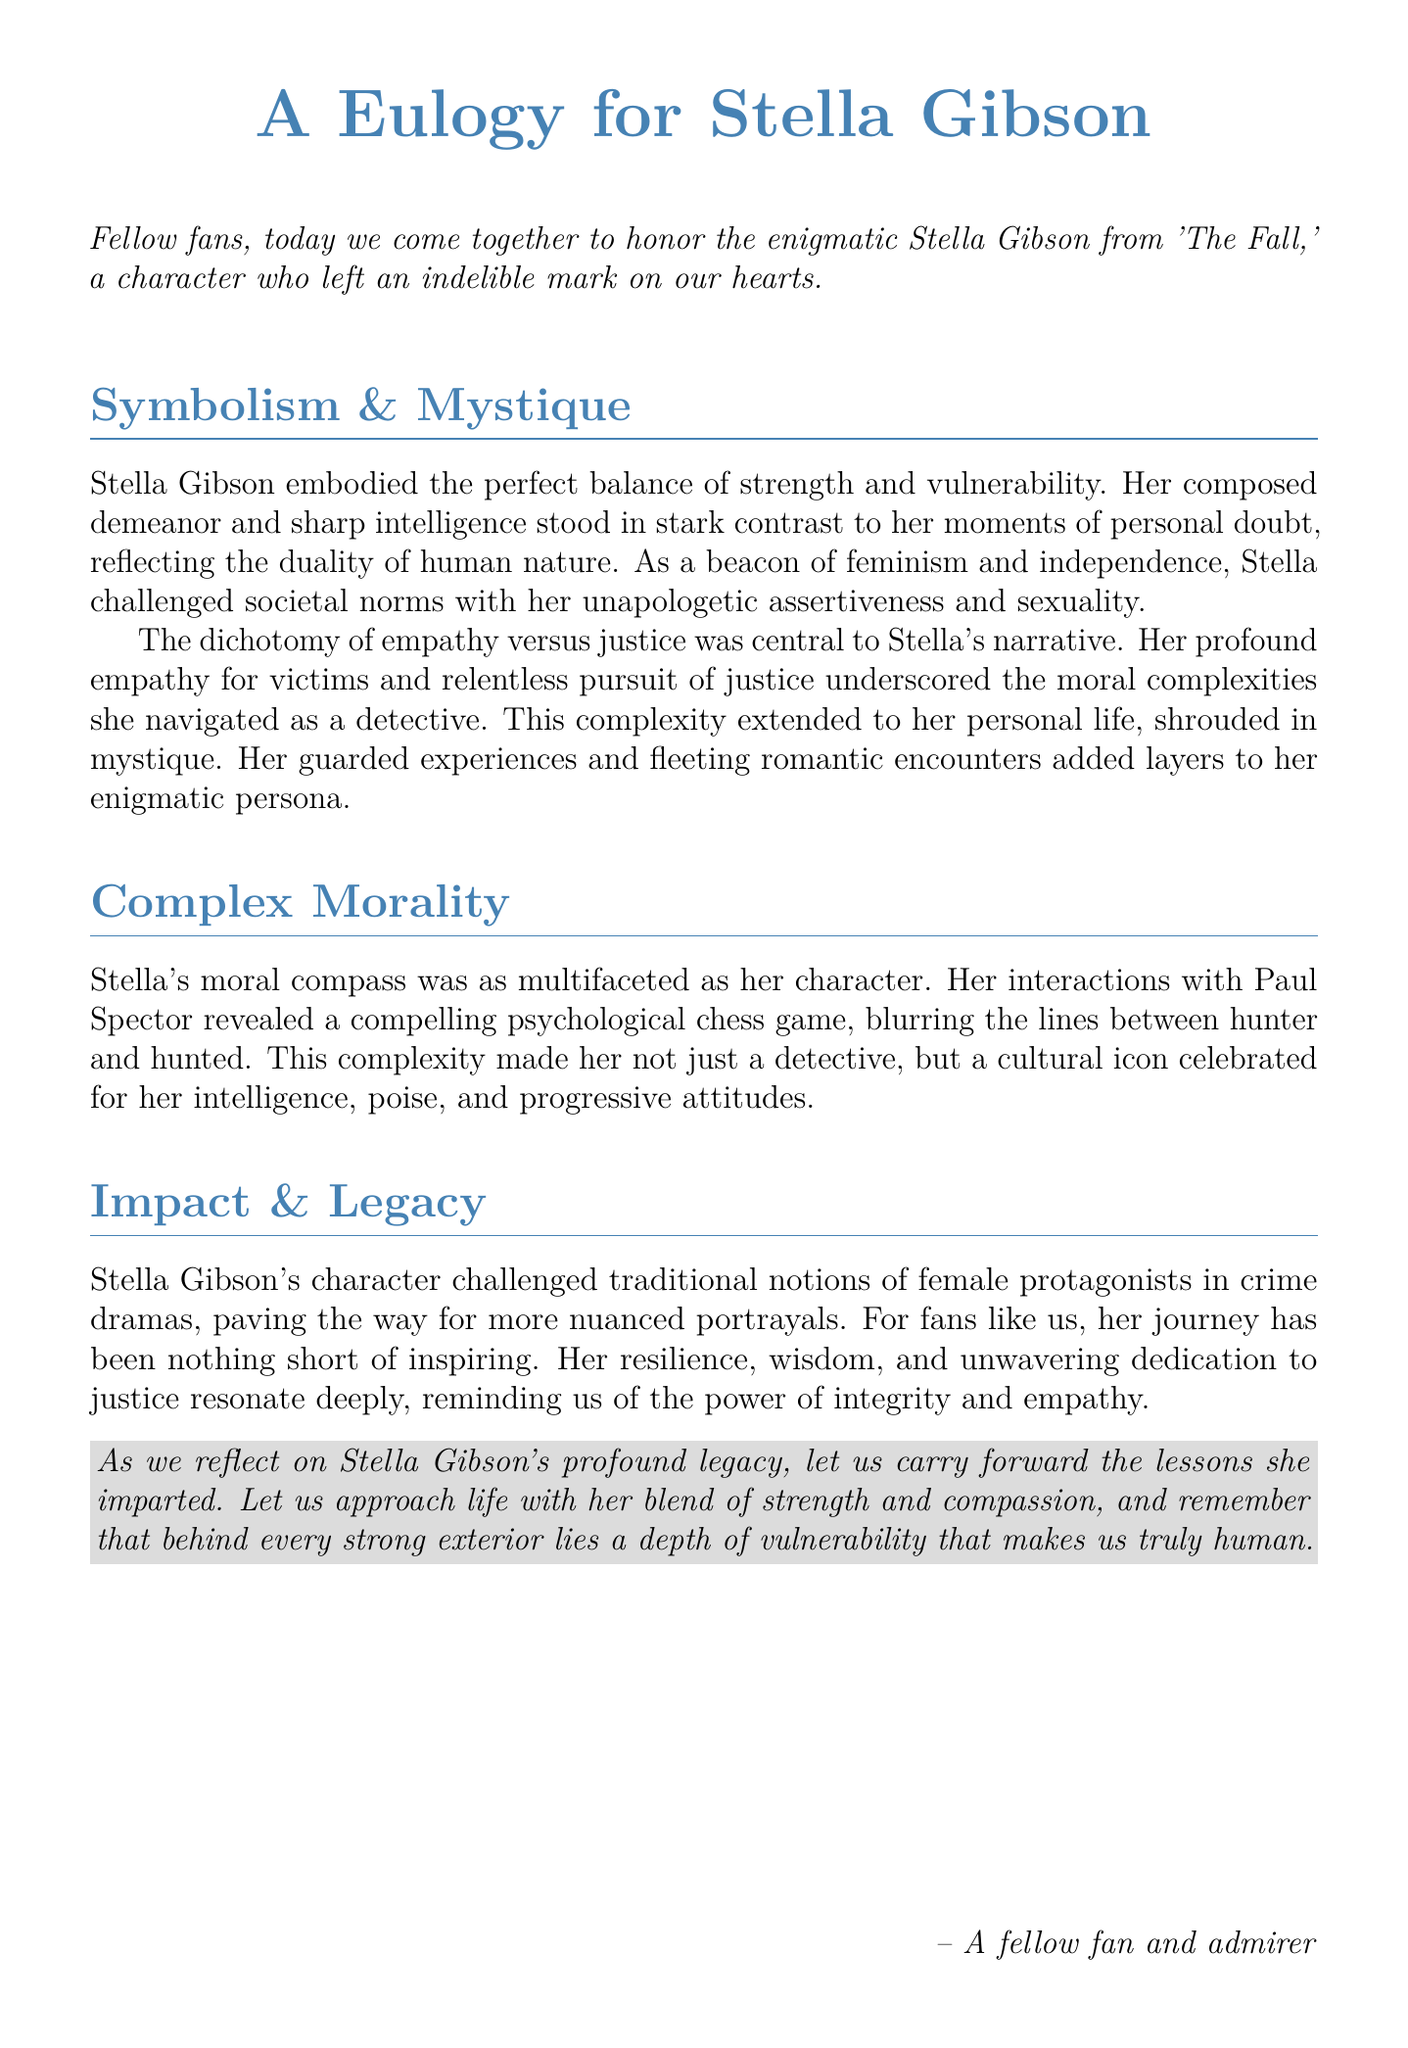what is the title of the document? The title of the document is clearly stated at the top as "A Eulogy for Stella Gibson".
Answer: A Eulogy for Stella Gibson who is the character being honored in this eulogy? The eulogy is honoring Stella Gibson, a character from 'The Fall'.
Answer: Stella Gibson what are the two contrasting traits of Stella Gibson mentioned in the eulogy? The eulogy highlights the traits of strength and vulnerability that Stella embodies.
Answer: strength and vulnerability what does Stella challenge according to the document? The document states that Stella challenged societal norms with her assertiveness and sexuality.
Answer: societal norms how was Stella's moral compass characterized? Stella's moral compass is described as multifaceted in the document, showing complexity.
Answer: multifaceted what is mentioned as a central theme of Stella's character narrative? The document identifies the dichotomy of empathy versus justice as a central theme of Stella's narrative.
Answer: empathy versus justice which character is implied to have a psychological chess game with Stella? The eulogy implies that Paul Spector engages in a psychological chess game with Stella.
Answer: Paul Spector how does the document summarize Stella Gibson's impact on female protagonists? Stella Gibson is credited with challenging traditional notions of female protagonists, making way for more nuanced portrayals.
Answer: challenging traditional notions what lesson does the author suggest we carry forward from Stella's legacy? The author suggests we carry forward the lessons of strength and compassion from Stella's legacy.
Answer: strength and compassion 